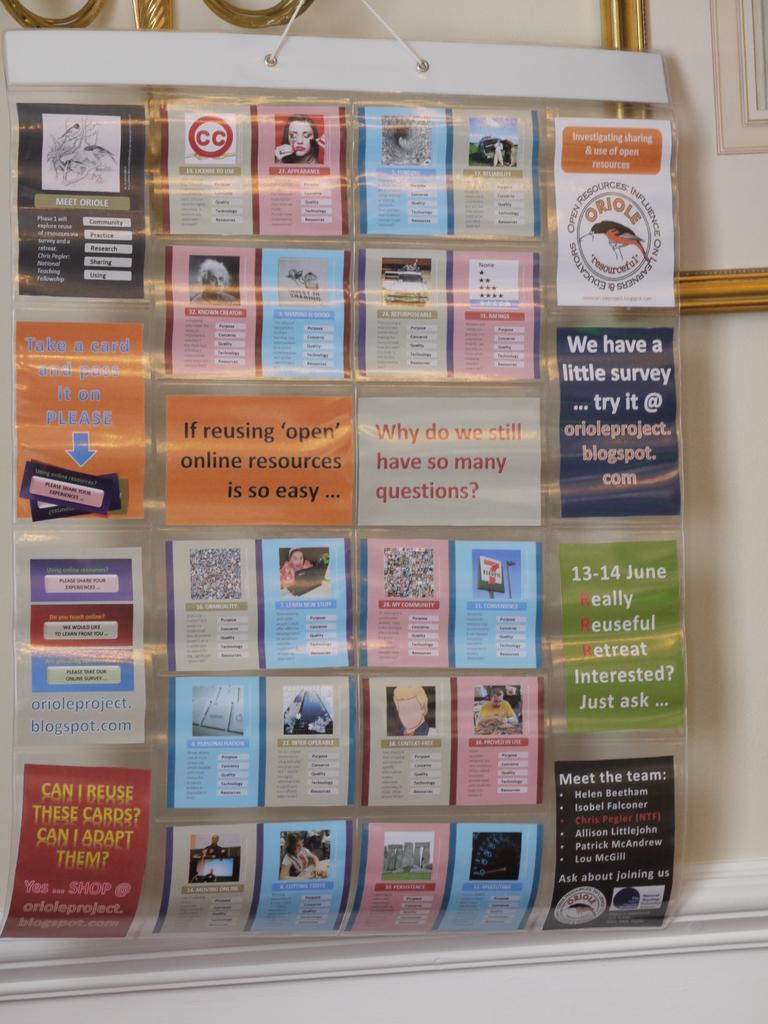<image>
Provide a brief description of the given image. Cards and posters on a wall with one that says "Why do we still have so many questions?". 